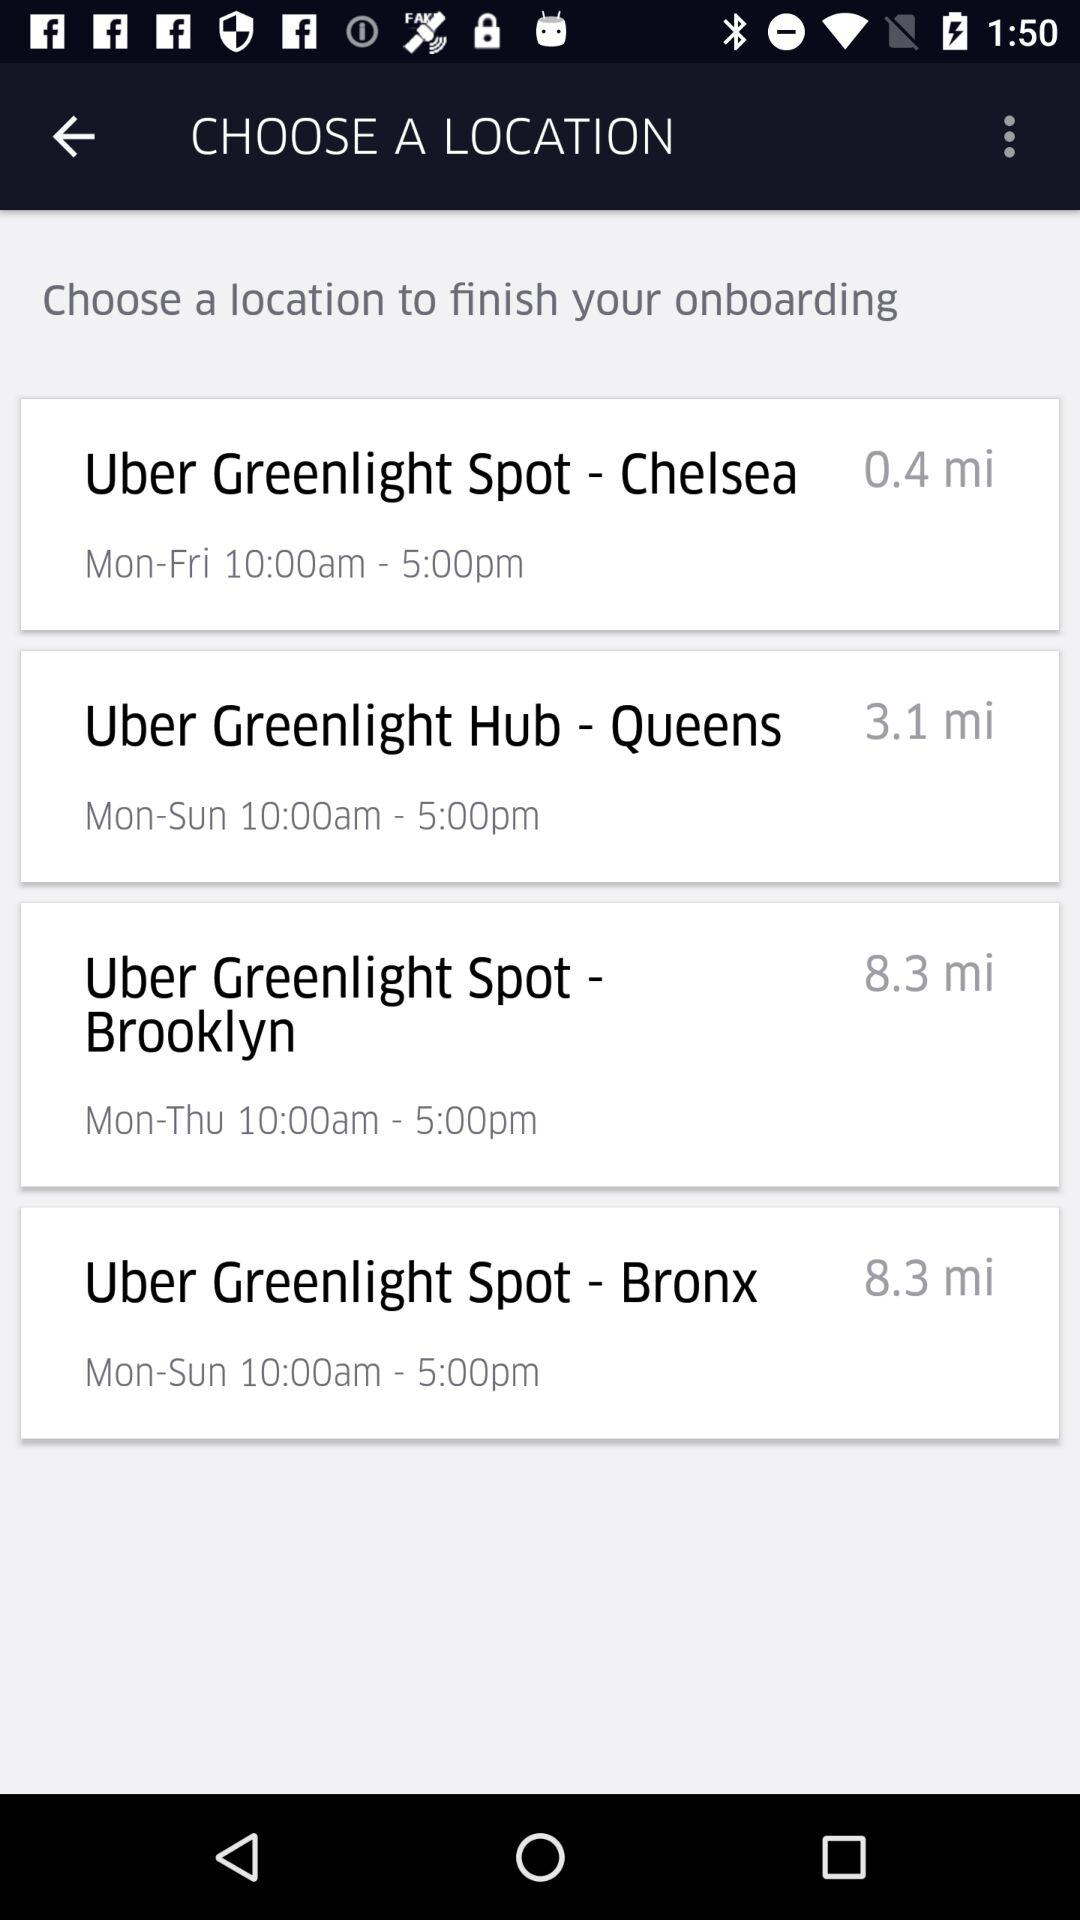What is the distance to "Uber Greenlight Hub -Queens"? The distance is 3.1 miles. 